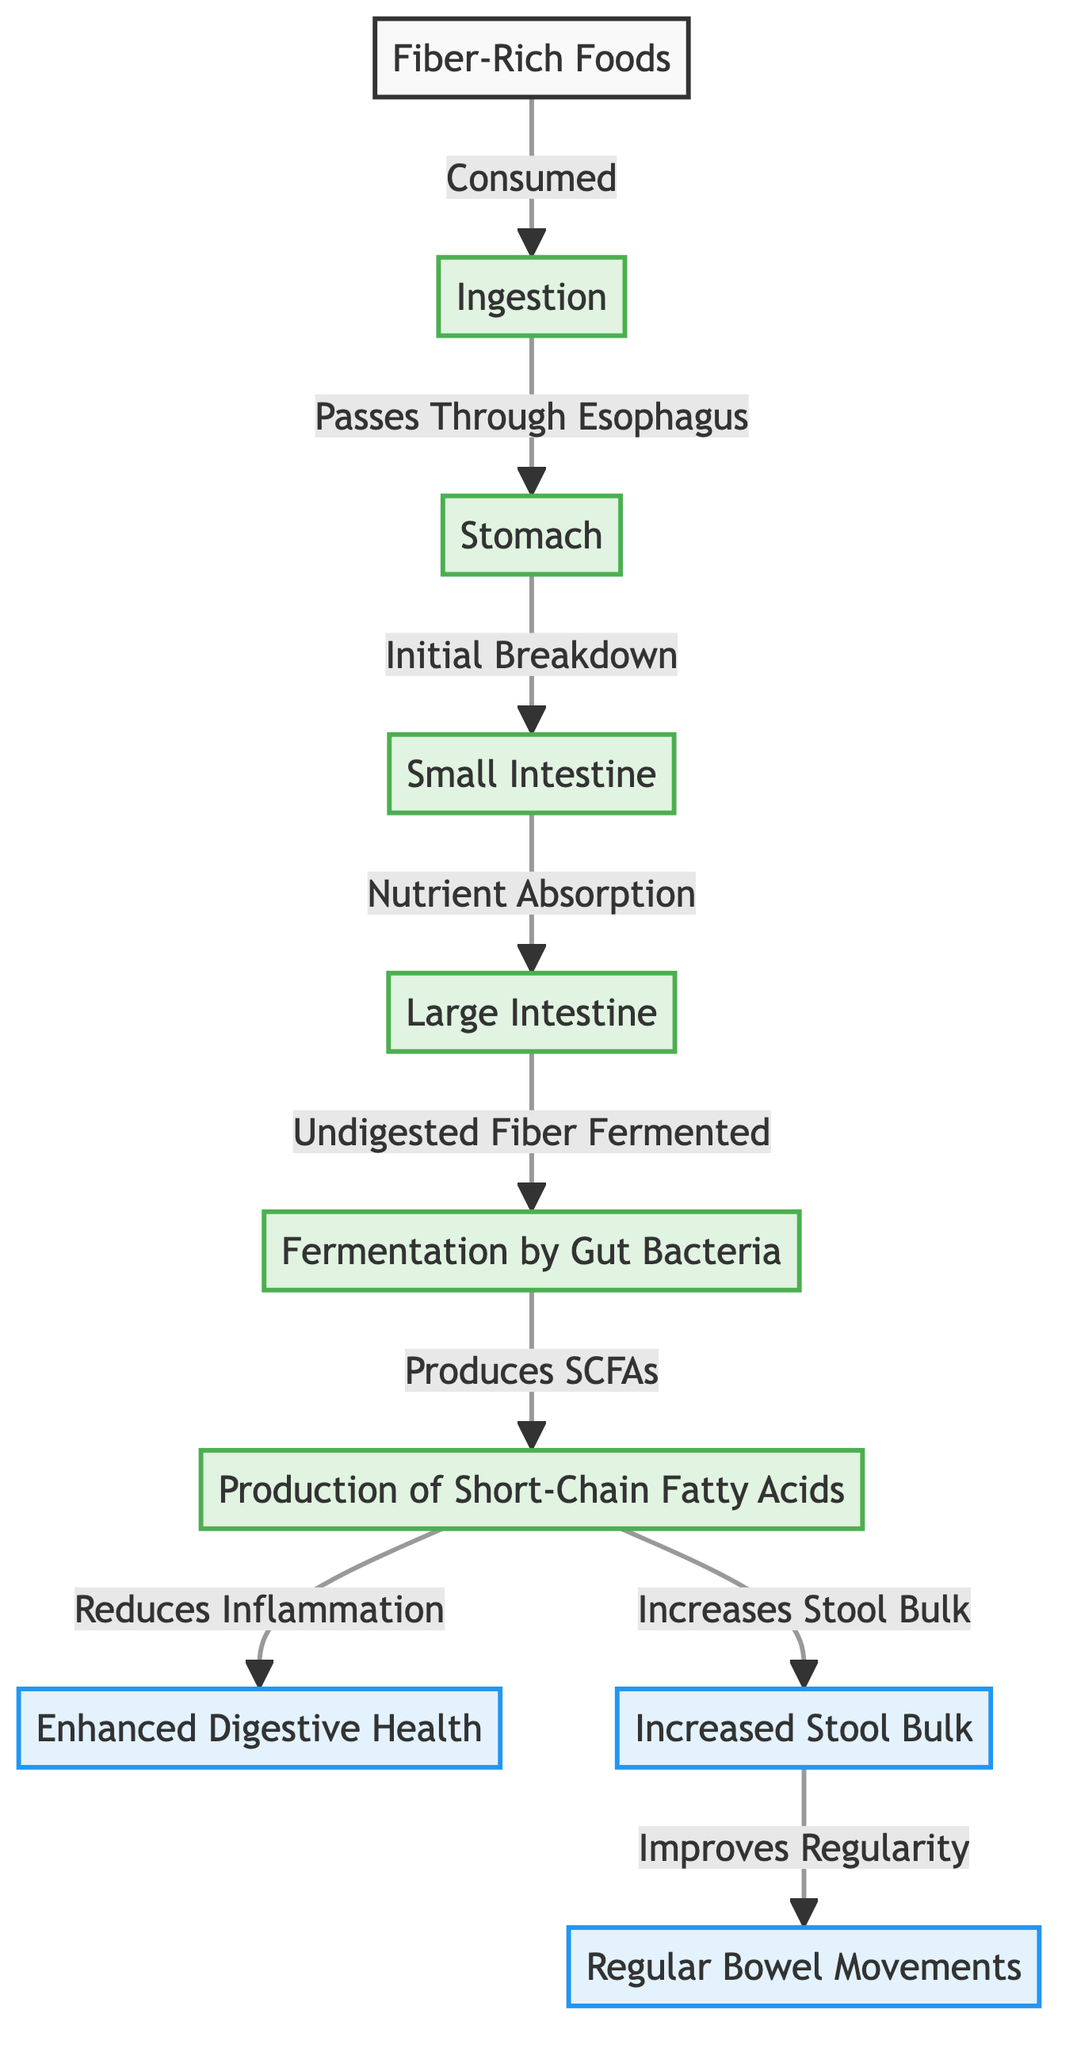What is the first step in the flowchart? The first step in the flowchart is "Fiber-Rich Foods," which is where the process begins. This node is the initial point of consumption before any digestive action occurs.
Answer: Fiber-Rich Foods How many major structures are included in the digestion process? The flowchart shows five major structures involved in the digestion process: Stomach, Small Intestine, Large Intestine, and Fermentation by Gut Bacteria.
Answer: Four What is produced during the fermentation by gut bacteria? The fermentation by gut bacteria leads to the production of "Short-Chain Fatty Acids" (SCFAs), which are important for digestive health.
Answer: Short-Chain Fatty Acids What does the production of SCFAs lead to? The production of SCFAs leads to two outcomes: "Reduces Inflammation" and "Increases Stool Bulk." This shows how SCFAs have a positive impact on digestive health.
Answer: Reduces Inflammation and Increases Stool Bulk How does increased stool bulk relate to bowel movements? Increased stool bulk improves regularity, meaning it enhances the frequency of bowel movements. This shows a direct relationship between these two benefits of fiber consumption.
Answer: Improves Regularity 